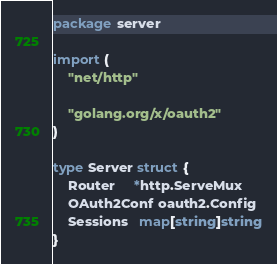<code> <loc_0><loc_0><loc_500><loc_500><_Go_>package server

import (
	"net/http"

	"golang.org/x/oauth2"
)

type Server struct {
	Router     *http.ServeMux
	OAuth2Conf oauth2.Config
	Sessions   map[string]string
}
</code> 